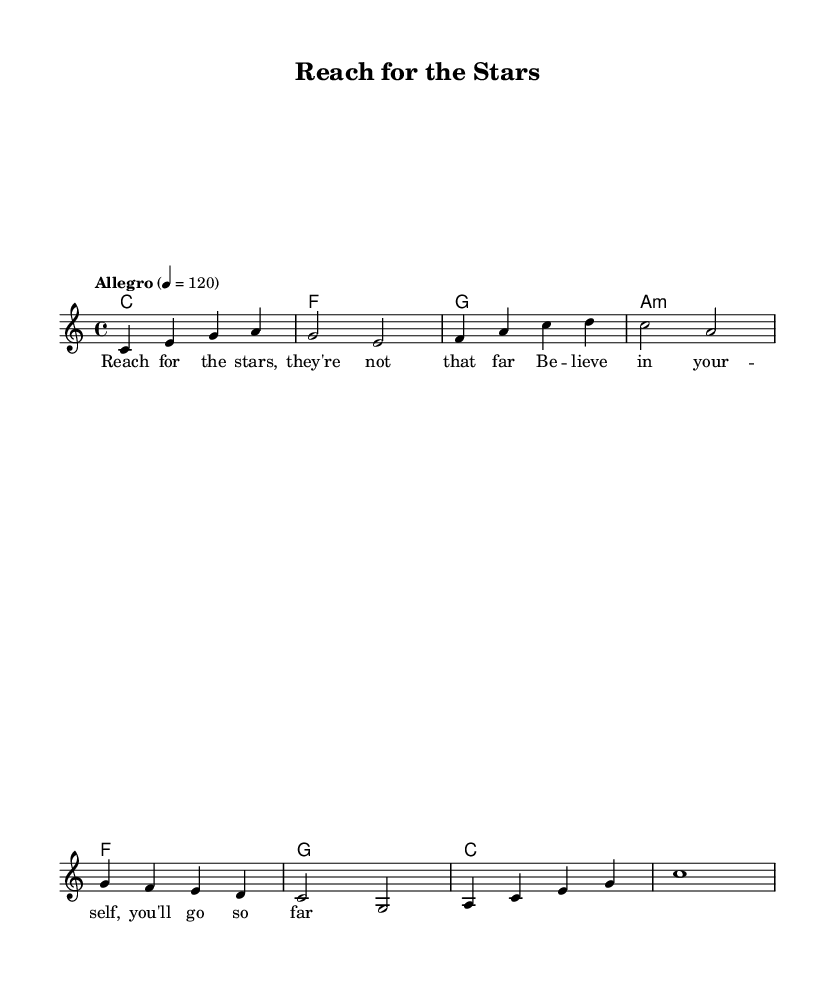What is the key signature of this music? The key signature is C major, indicated by the absence of sharps or flats in the notation. You can determine the key signature by looking at the beginning of the staff where the key is notated.
Answer: C major What is the time signature of this music? The time signature is 4/4, which is commonly referred to as "common time." This can be identified by looking at the numbers at the beginning of the score, where the upper number indicates four beats per measure and the lower number indicates a quarter note gets one beat.
Answer: 4/4 What is the tempo marking of the piece? The tempo marking is "Allegro" with a metronome marking of 120 beats per minute. This is stated at the beginning of the score, providing guidance on the speed at which the music should be played.
Answer: Allegro 4 = 120 How many measures are in the melody? The melody consists of eight measures. This can be counted by looking at the number of vertical lines (bar lines) that separate the music, as each section between two bar lines is considered one measure.
Answer: 8 What is the last note of the melody? The last note of the melody is C. You can find this by looking at the final pitch in the melody part, which appears just before the end of the staff notation, signifying the conclusion of this melodic line.
Answer: C What is the first lyric line of the song? The first lyric line is "Reach for the stars, they're not that far." This can be seen beneath the melody staff, where the lyrics are aligned with the corresponding notes, providing the text to be sung.
Answer: Reach for the stars, they're not that far What is the chord played in the second measure? The chord played in the second measure is F major. Chords are denoted in the chord names section above the staff, and the second chord in the sequence indicates F major being played in that measure.
Answer: F 